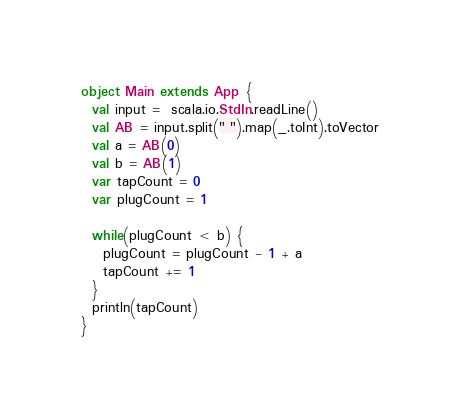<code> <loc_0><loc_0><loc_500><loc_500><_Scala_>object Main extends App {
  val input =  scala.io.StdIn.readLine()
  val AB = input.split(" ").map(_.toInt).toVector
  val a = AB(0)
  val b = AB(1)
  var tapCount = 0
  var plugCount = 1

  while(plugCount < b) {
    plugCount = plugCount - 1 + a
    tapCount += 1
  }
  println(tapCount)
}</code> 